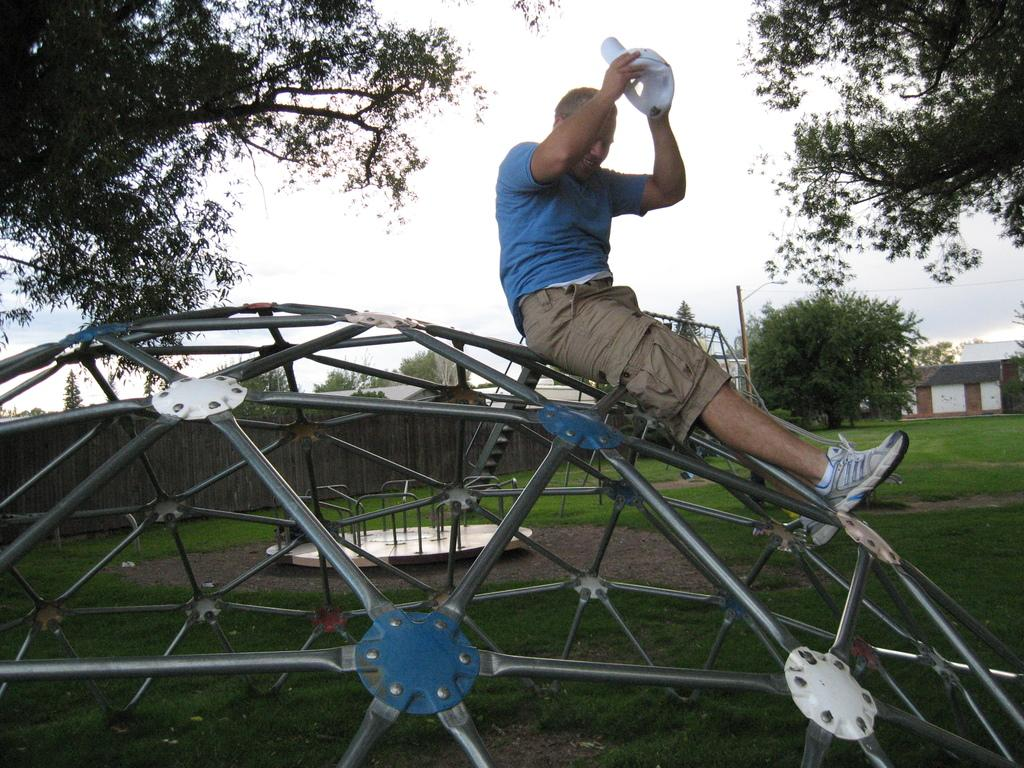What is the man in the image sitting on? The man is sitting on a metal object. What is the man holding in the image? The man is holding a cap with his hands. What type of vegetation can be seen in the image? There is grass and trees visible in the image. What structures can be seen in the image? There is a wall and a house in the image. What is visible in the background of the image? The sky is visible in the background of the image. How many doors can be seen in the image? There is no door visible in the image. What type of recess is present in the trees in the image? There is no recess present in the trees in the image; the trees are simply visible in the image. 